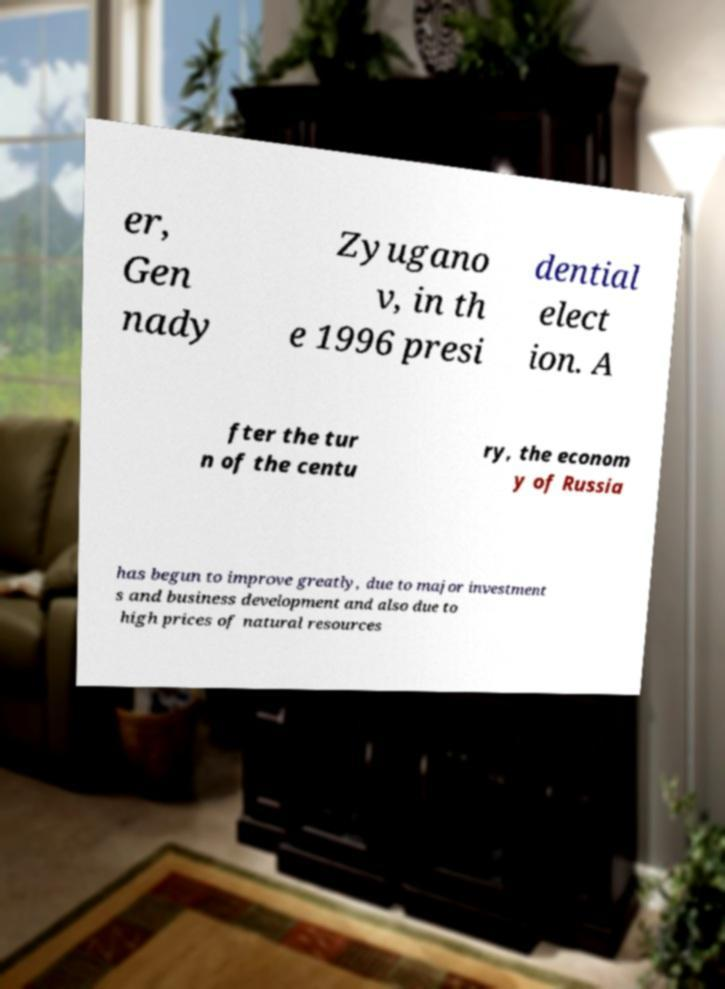Can you accurately transcribe the text from the provided image for me? er, Gen nady Zyugano v, in th e 1996 presi dential elect ion. A fter the tur n of the centu ry, the econom y of Russia has begun to improve greatly, due to major investment s and business development and also due to high prices of natural resources 